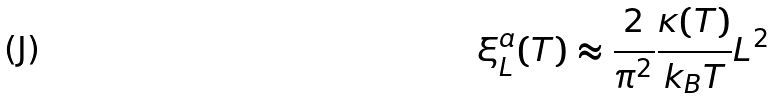Convert formula to latex. <formula><loc_0><loc_0><loc_500><loc_500>\xi ^ { a } _ { L } ( T ) \approx \frac { 2 } { \pi ^ { 2 } } \frac { \kappa ( T ) } { k _ { B } T } L ^ { 2 }</formula> 